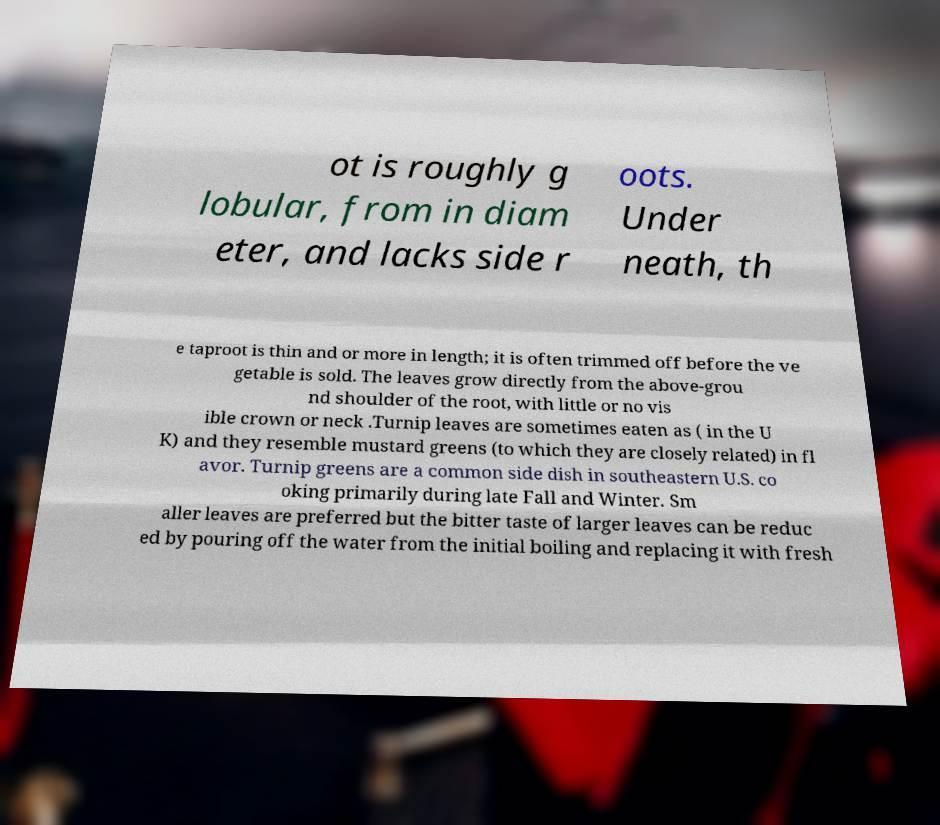There's text embedded in this image that I need extracted. Can you transcribe it verbatim? ot is roughly g lobular, from in diam eter, and lacks side r oots. Under neath, th e taproot is thin and or more in length; it is often trimmed off before the ve getable is sold. The leaves grow directly from the above-grou nd shoulder of the root, with little or no vis ible crown or neck .Turnip leaves are sometimes eaten as ( in the U K) and they resemble mustard greens (to which they are closely related) in fl avor. Turnip greens are a common side dish in southeastern U.S. co oking primarily during late Fall and Winter. Sm aller leaves are preferred but the bitter taste of larger leaves can be reduc ed by pouring off the water from the initial boiling and replacing it with fresh 